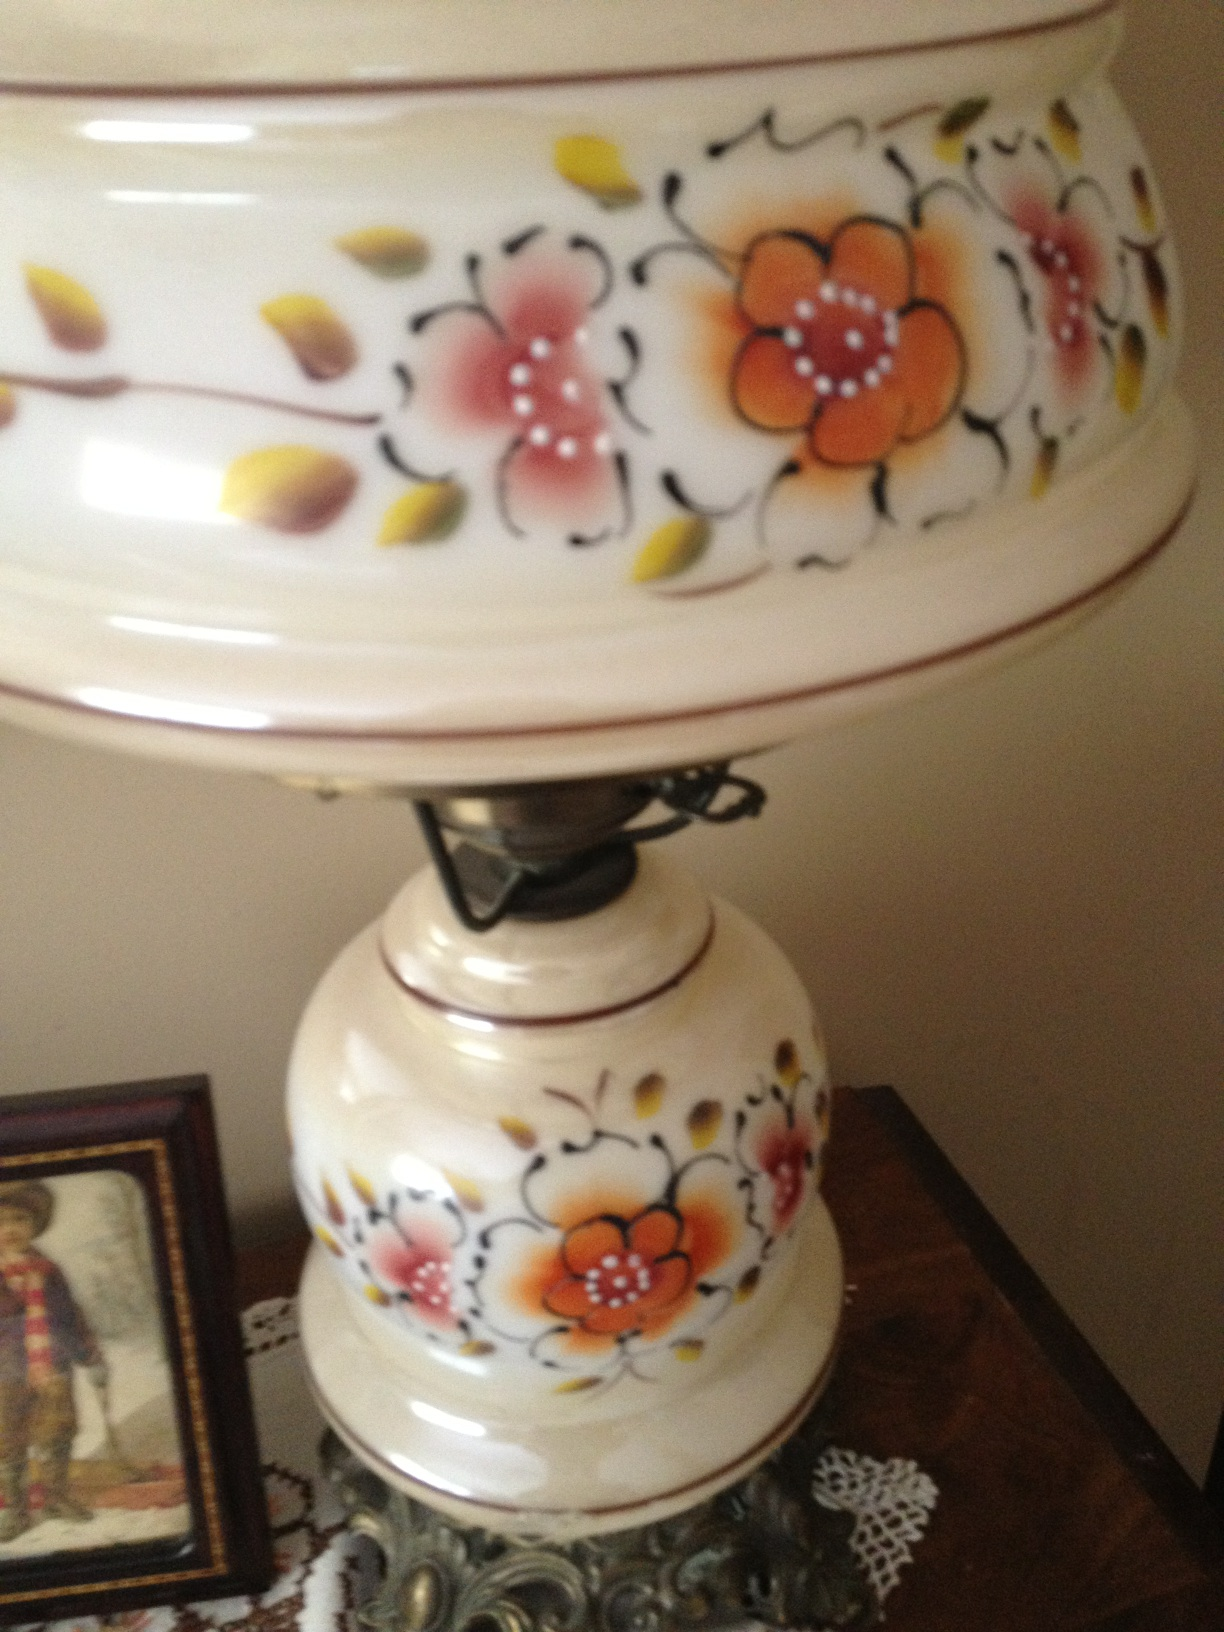Can you tell more about the design on this object? The object is adorned with a vibrant floral pattern, including orange and pink flowers linked by delicate black lines, interspersed with scattered yellow and green leaves. This design could be indicative of a specific cultural art style, often aimed to represent natural beauty and elegance. What could be the cultural significance of this item? Items like this are often used in ceremonial or formal settings, especially in cultures where tea drinking is a significant tradition. The elaborate design suggests it might be intended for use on special occasions, symbolizing hospitality and grace. 